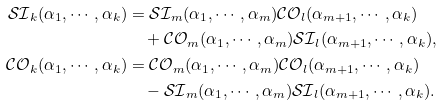Convert formula to latex. <formula><loc_0><loc_0><loc_500><loc_500>\mathcal { S I } _ { k } ( \alpha _ { 1 } , \cdots , \alpha _ { k } ) & = \mathcal { S I } _ { m } ( \alpha _ { 1 } , \cdots , \alpha _ { m } ) \mathcal { C O } _ { l } ( \alpha _ { m + 1 } , \cdots , \alpha _ { k } ) \\ & \quad + \mathcal { C O } _ { m } ( \alpha _ { 1 } , \cdots , \alpha _ { m } ) \mathcal { S I } _ { l } ( \alpha _ { m + 1 } , \cdots , \alpha _ { k } ) , \\ \mathcal { C O } _ { k } ( \alpha _ { 1 } , \cdots , \alpha _ { k } ) & = \mathcal { C O } _ { m } ( \alpha _ { 1 } , \cdots , \alpha _ { m } ) \mathcal { C O } _ { l } ( \alpha _ { m + 1 } , \cdots , \alpha _ { k } ) \\ & \quad - \mathcal { S I } _ { m } ( \alpha _ { 1 } , \cdots , \alpha _ { m } ) \mathcal { S I } _ { l } ( \alpha _ { m + 1 } , \cdots , \alpha _ { k } ) .</formula> 